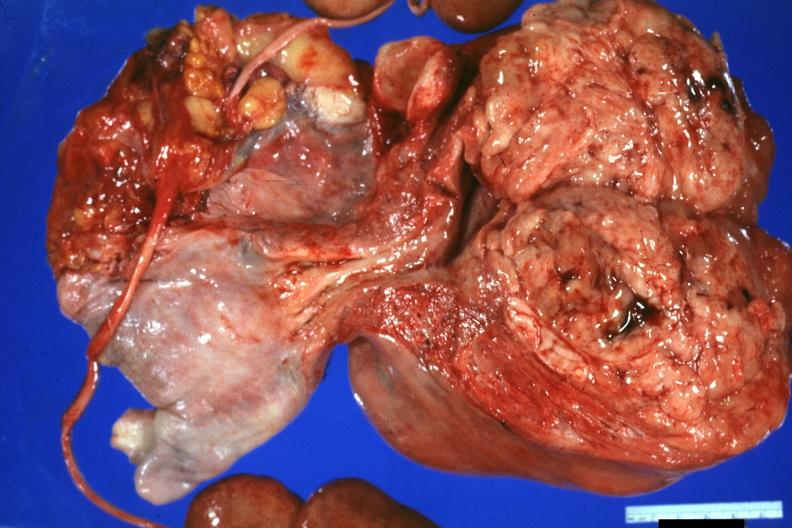what is present?
Answer the question using a single word or phrase. Female reproductive 